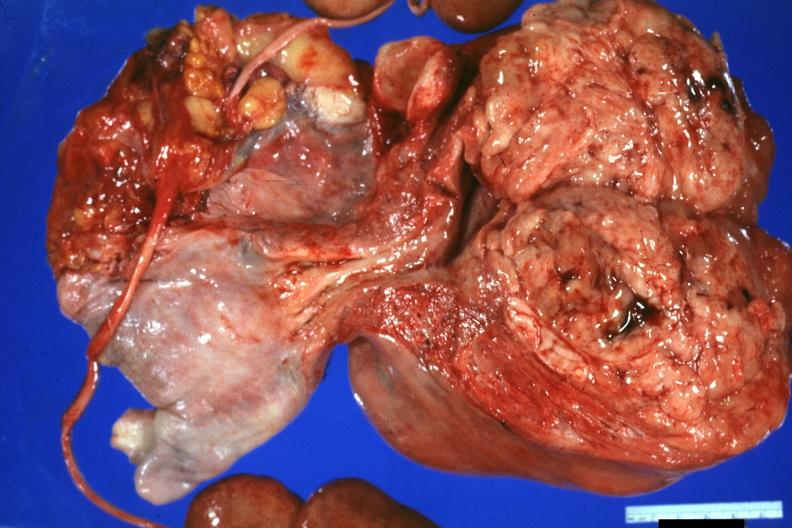what is present?
Answer the question using a single word or phrase. Female reproductive 